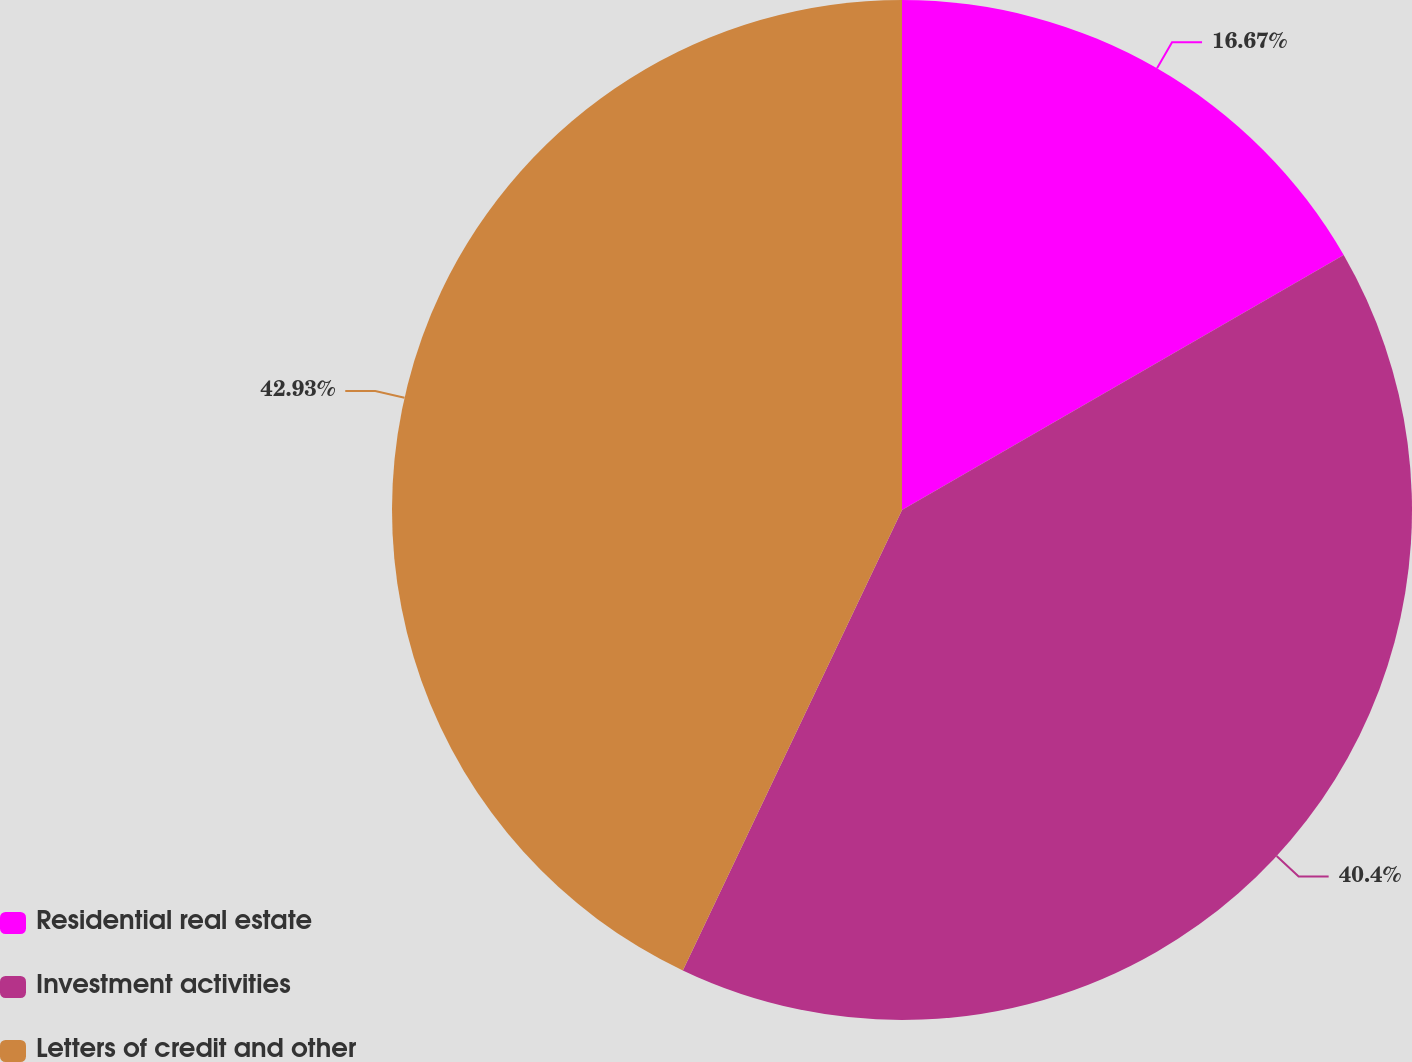Convert chart. <chart><loc_0><loc_0><loc_500><loc_500><pie_chart><fcel>Residential real estate<fcel>Investment activities<fcel>Letters of credit and other<nl><fcel>16.67%<fcel>40.4%<fcel>42.93%<nl></chart> 